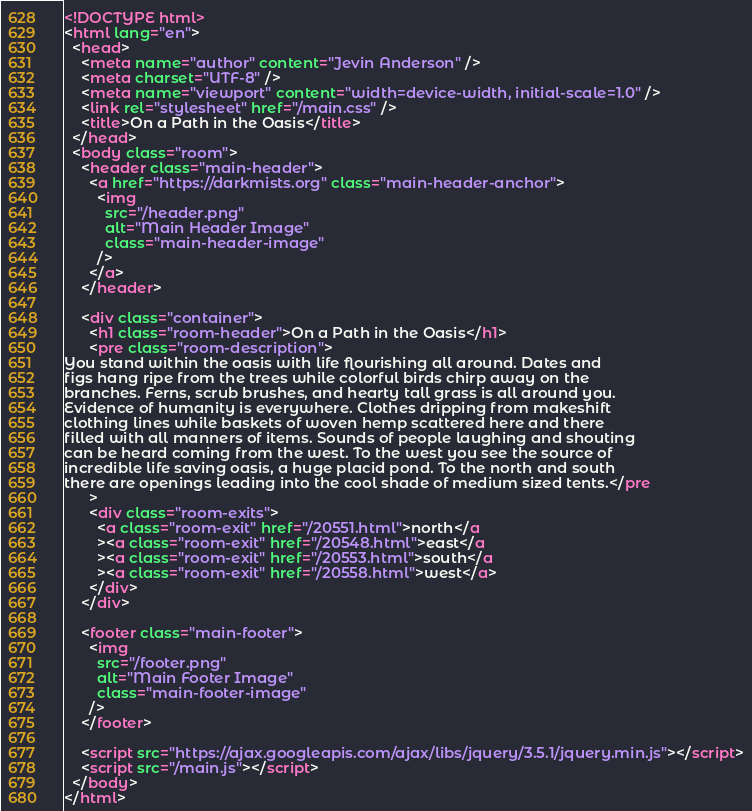<code> <loc_0><loc_0><loc_500><loc_500><_HTML_><!DOCTYPE html>
<html lang="en">
  <head>
    <meta name="author" content="Jevin Anderson" />
    <meta charset="UTF-8" />
    <meta name="viewport" content="width=device-width, initial-scale=1.0" />
    <link rel="stylesheet" href="/main.css" />
    <title>On a Path in the Oasis</title>
  </head>
  <body class="room">
    <header class="main-header">
      <a href="https://darkmists.org" class="main-header-anchor">
        <img
          src="/header.png"
          alt="Main Header Image"
          class="main-header-image"
        />
      </a>
    </header>

    <div class="container">
      <h1 class="room-header">On a Path in the Oasis</h1>
      <pre class="room-description">
You stand within the oasis with life flourishing all around. Dates and
figs hang ripe from the trees while colorful birds chirp away on the
branches. Ferns, scrub brushes, and hearty tall grass is all around you.
Evidence of humanity is everywhere. Clothes dripping from makeshift
clothing lines while baskets of woven hemp scattered here and there
filled with all manners of items. Sounds of people laughing and shouting
can be heard coming from the west. To the west you see the source of
incredible life saving oasis, a huge placid pond. To the north and south
there are openings leading into the cool shade of medium sized tents.</pre
      >
      <div class="room-exits">
        <a class="room-exit" href="/20551.html">north</a
        ><a class="room-exit" href="/20548.html">east</a
        ><a class="room-exit" href="/20553.html">south</a
        ><a class="room-exit" href="/20558.html">west</a>
      </div>
    </div>

    <footer class="main-footer">
      <img
        src="/footer.png"
        alt="Main Footer Image"
        class="main-footer-image"
      />
    </footer>

    <script src="https://ajax.googleapis.com/ajax/libs/jquery/3.5.1/jquery.min.js"></script>
    <script src="/main.js"></script>
  </body>
</html>
</code> 